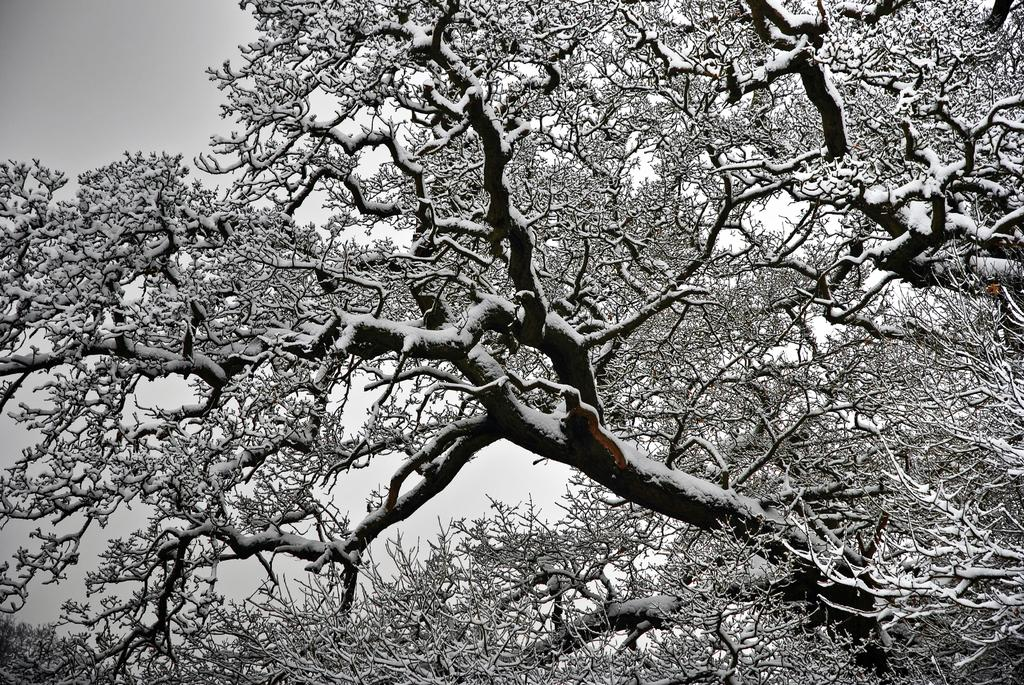What type of picture is in the image? The image contains a black and white picture. What natural elements can be seen in the image? There are trees in the image. What part of the natural environment is visible in the image? The sky is visible in the image. What type of gate is present in the image? There is no gate present in the image; it contains a black and white picture, trees, and the sky. 